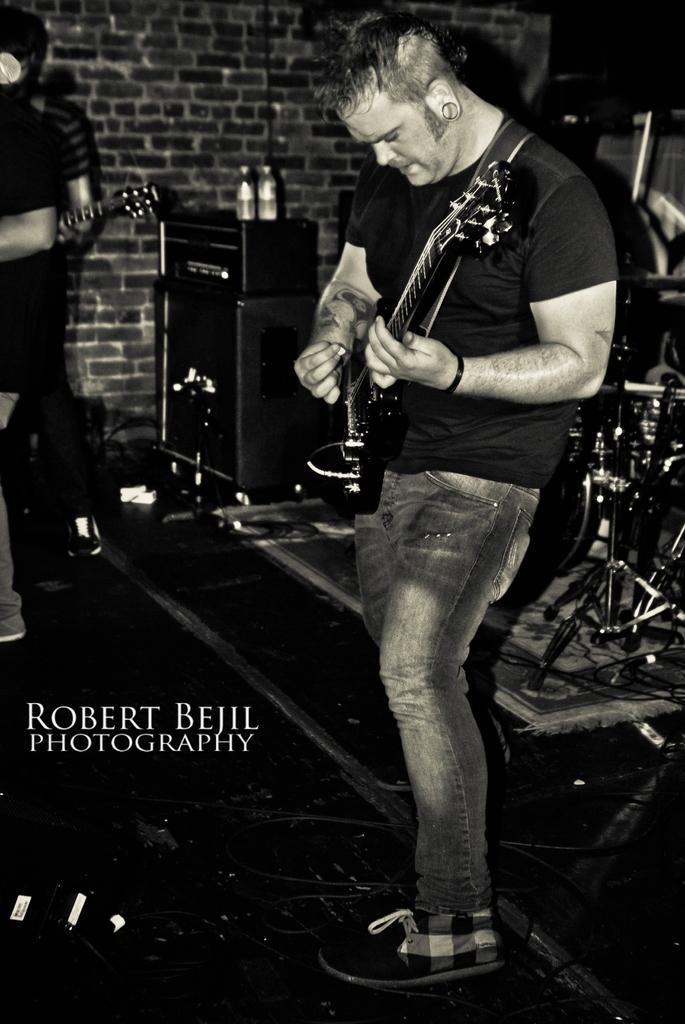Could you give a brief overview of what you see in this image? A man is holding a guitar and playing. In the background there are drums, tables, on the table there are bottles, a brick wall. And other persons are standing and holding guitar. 